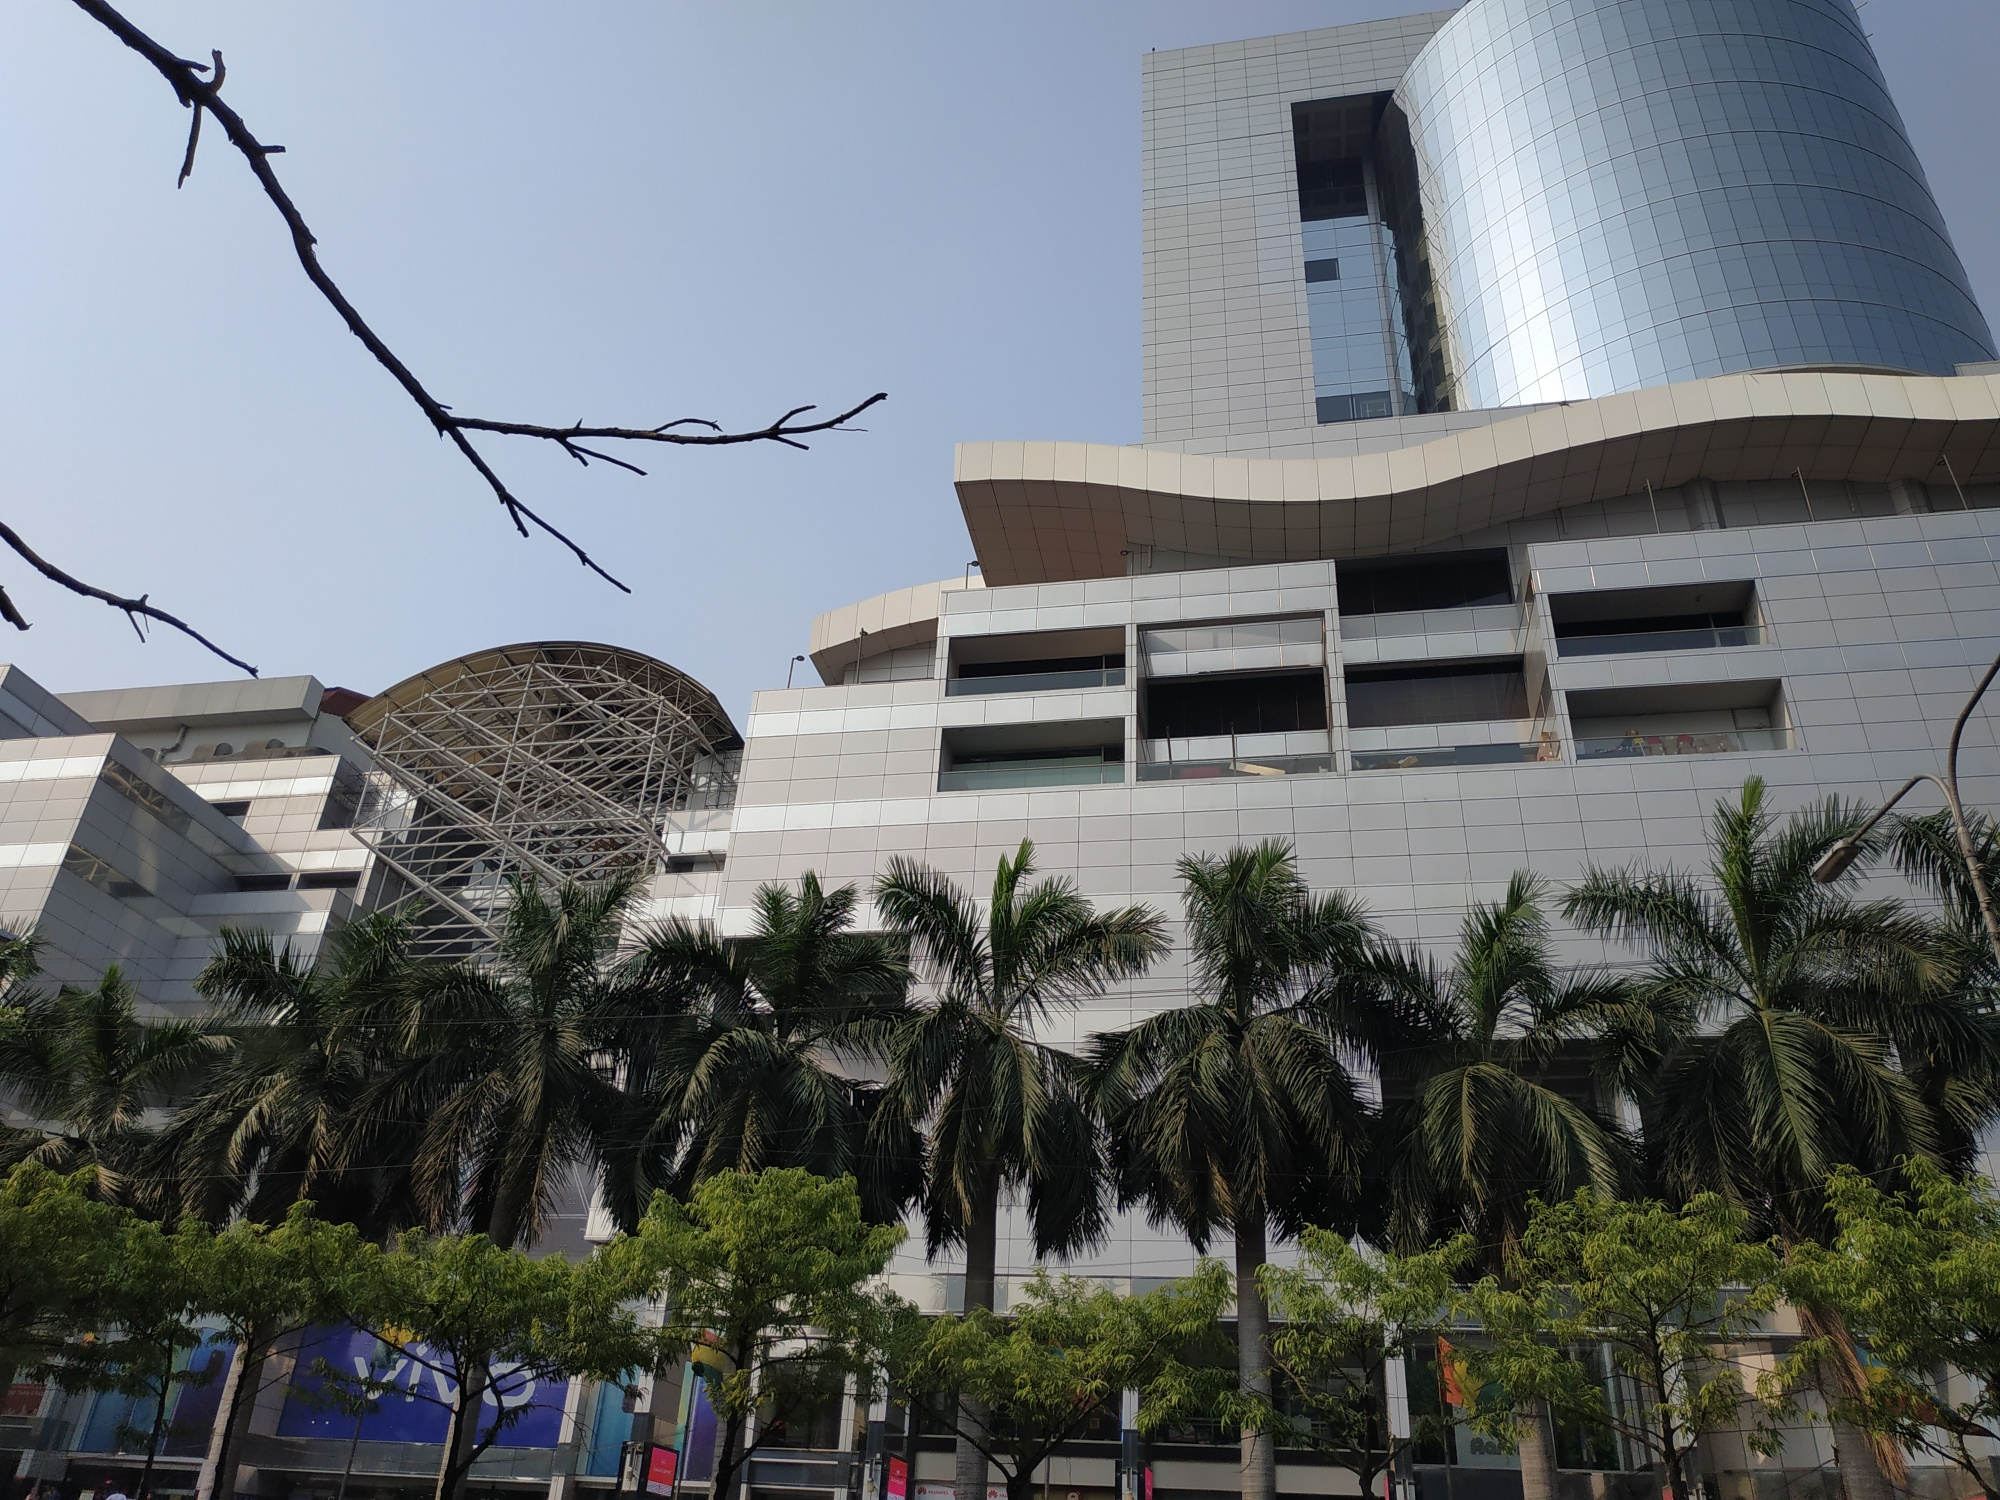Predict some advancements this building might feature in 50 years. In 50 years, this building could incorporate numerous advancements reflecting the future of human innovation. The glass facade might include smart window technology that adjusts transparency and tint based on lighting conditions, maximizing energy efficiency. The structure could feature an integrated AI system allowing for enhanced building management, from energy usage to security protocols. Augmented reality (AR) and virtual reality (VR) areas might be standard, offering immersive experiences for visitors and workers. The building could also boast vertical gardens and green roofs, improving air quality and providing fresh produce. Advanced sustainability measures, such as rainwater harvesting and solar energy harnessing, would be prominent. Additionally, autonomous systems for cleaning and maintenance would ensure the building remains in pristine condition with minimal human intervention. Overall, this building would epitomize futuristic architecture and sustainable living. 